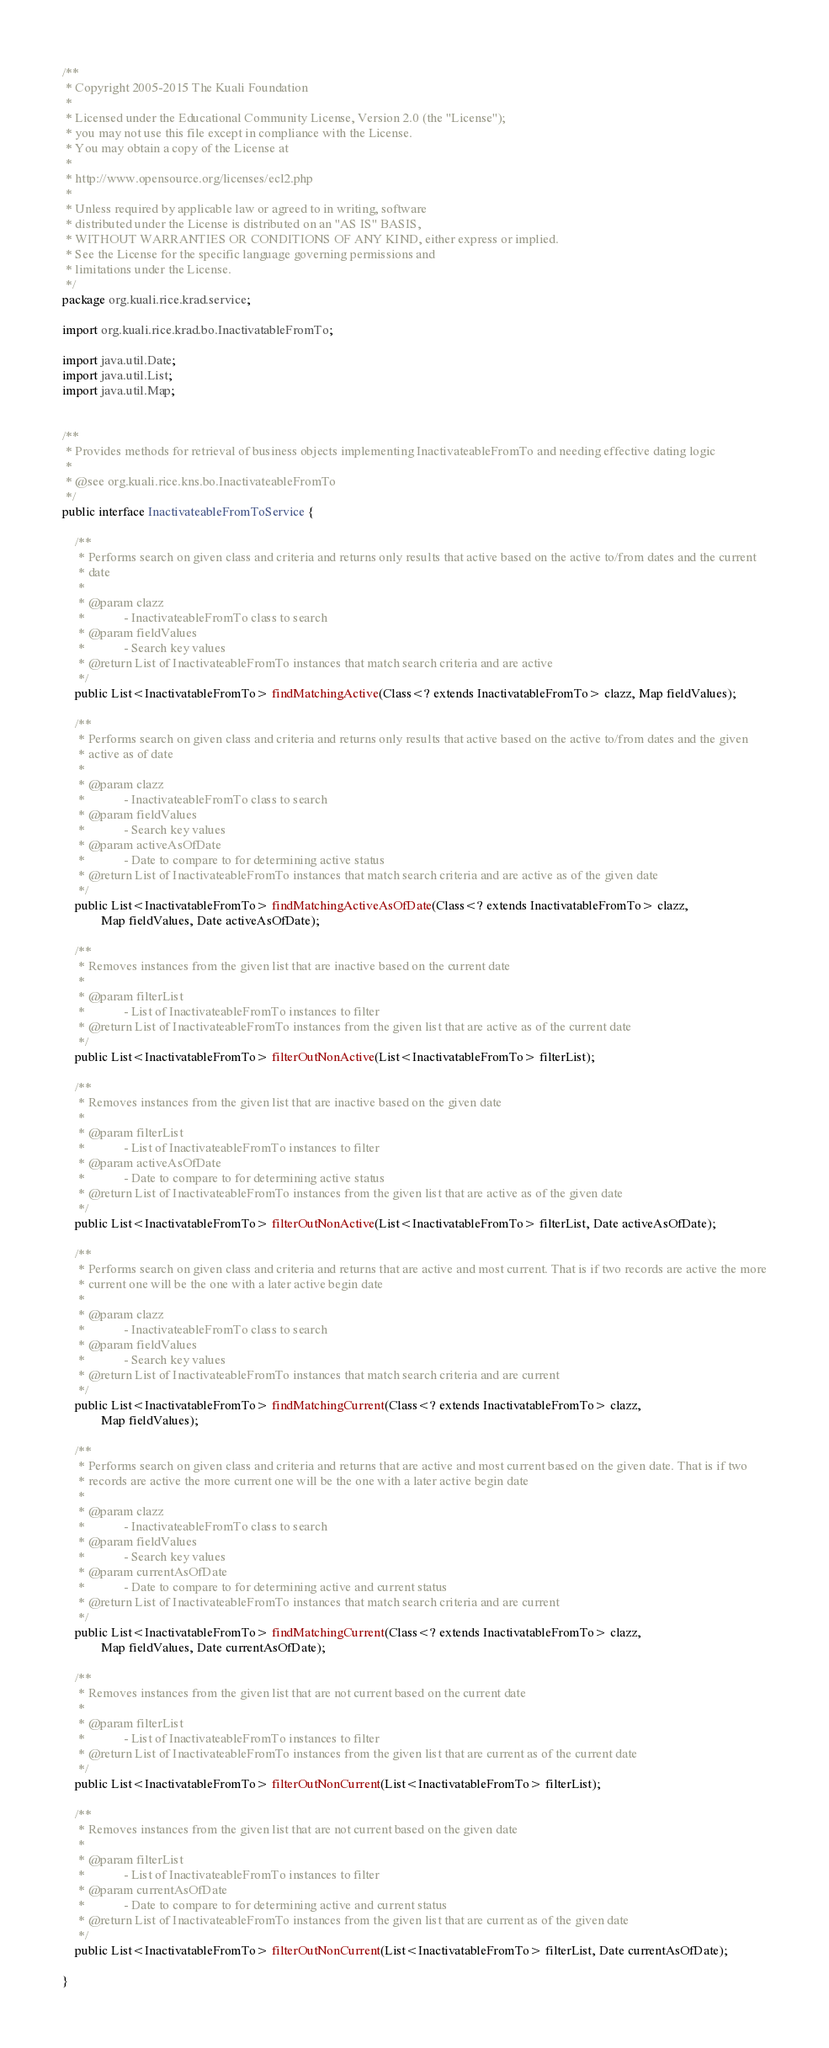<code> <loc_0><loc_0><loc_500><loc_500><_Java_>/**
 * Copyright 2005-2015 The Kuali Foundation
 *
 * Licensed under the Educational Community License, Version 2.0 (the "License");
 * you may not use this file except in compliance with the License.
 * You may obtain a copy of the License at
 *
 * http://www.opensource.org/licenses/ecl2.php
 *
 * Unless required by applicable law or agreed to in writing, software
 * distributed under the License is distributed on an "AS IS" BASIS,
 * WITHOUT WARRANTIES OR CONDITIONS OF ANY KIND, either express or implied.
 * See the License for the specific language governing permissions and
 * limitations under the License.
 */
package org.kuali.rice.krad.service;

import org.kuali.rice.krad.bo.InactivatableFromTo;

import java.util.Date;
import java.util.List;
import java.util.Map;


/**
 * Provides methods for retrieval of business objects implementing InactivateableFromTo and needing effective dating logic
 * 
 * @see org.kuali.rice.kns.bo.InactivateableFromTo
 */
public interface InactivateableFromToService {

	/**
	 * Performs search on given class and criteria and returns only results that active based on the active to/from dates and the current
	 * date
	 * 
	 * @param clazz
	 *            - InactivateableFromTo class to search
	 * @param fieldValues
	 *            - Search key values
	 * @return List of InactivateableFromTo instances that match search criteria and are active
	 */
	public List<InactivatableFromTo> findMatchingActive(Class<? extends InactivatableFromTo> clazz, Map fieldValues);

	/**
	 * Performs search on given class and criteria and returns only results that active based on the active to/from dates and the given
	 * active as of date
	 * 
	 * @param clazz
	 *            - InactivateableFromTo class to search
	 * @param fieldValues
	 *            - Search key values
	 * @param activeAsOfDate
	 *            - Date to compare to for determining active status
	 * @return List of InactivateableFromTo instances that match search criteria and are active as of the given date
	 */
	public List<InactivatableFromTo> findMatchingActiveAsOfDate(Class<? extends InactivatableFromTo> clazz,
			Map fieldValues, Date activeAsOfDate);

	/**
	 * Removes instances from the given list that are inactive based on the current date
	 * 
	 * @param filterList
	 *            - List of InactivateableFromTo instances to filter
	 * @return List of InactivateableFromTo instances from the given list that are active as of the current date
	 */
	public List<InactivatableFromTo> filterOutNonActive(List<InactivatableFromTo> filterList);

	/**
	 * Removes instances from the given list that are inactive based on the given date
	 * 
	 * @param filterList
	 *            - List of InactivateableFromTo instances to filter
	 * @param activeAsOfDate
	 *            - Date to compare to for determining active status
	 * @return List of InactivateableFromTo instances from the given list that are active as of the given date
	 */
	public List<InactivatableFromTo> filterOutNonActive(List<InactivatableFromTo> filterList, Date activeAsOfDate);

	/**
	 * Performs search on given class and criteria and returns that are active and most current. That is if two records are active the more
	 * current one will be the one with a later active begin date
	 * 
	 * @param clazz
	 *            - InactivateableFromTo class to search
	 * @param fieldValues
	 *            - Search key values
	 * @return List of InactivateableFromTo instances that match search criteria and are current
	 */
	public List<InactivatableFromTo> findMatchingCurrent(Class<? extends InactivatableFromTo> clazz,
			Map fieldValues);

	/**
	 * Performs search on given class and criteria and returns that are active and most current based on the given date. That is if two
	 * records are active the more current one will be the one with a later active begin date
	 * 
	 * @param clazz
	 *            - InactivateableFromTo class to search
	 * @param fieldValues
	 *            - Search key values
	 * @param currentAsOfDate
	 *            - Date to compare to for determining active and current status
	 * @return List of InactivateableFromTo instances that match search criteria and are current
	 */
	public List<InactivatableFromTo> findMatchingCurrent(Class<? extends InactivatableFromTo> clazz,
			Map fieldValues, Date currentAsOfDate);

	/**
	 * Removes instances from the given list that are not current based on the current date
	 * 
	 * @param filterList
	 *            - List of InactivateableFromTo instances to filter
	 * @return List of InactivateableFromTo instances from the given list that are current as of the current date
	 */
	public List<InactivatableFromTo> filterOutNonCurrent(List<InactivatableFromTo> filterList);

	/**
	 * Removes instances from the given list that are not current based on the given date
	 * 
	 * @param filterList
	 *            - List of InactivateableFromTo instances to filter
	 * @param currentAsOfDate
	 *            - Date to compare to for determining active and current status
	 * @return List of InactivateableFromTo instances from the given list that are current as of the given date
	 */
	public List<InactivatableFromTo> filterOutNonCurrent(List<InactivatableFromTo> filterList, Date currentAsOfDate);

}
</code> 